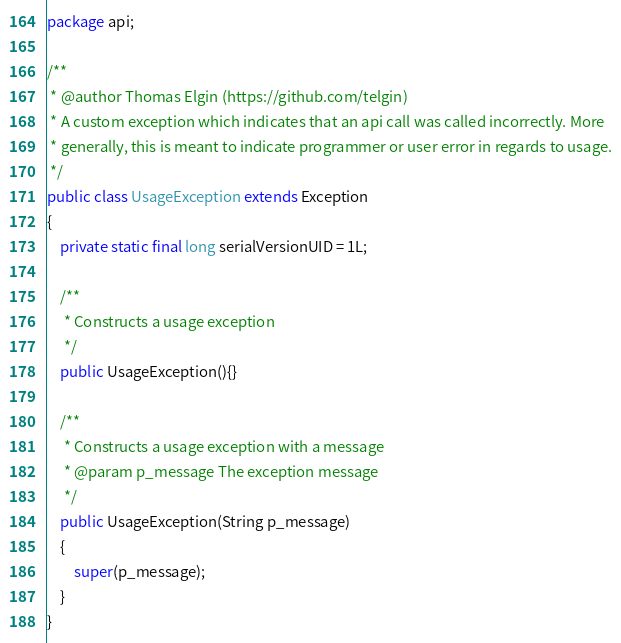Convert code to text. <code><loc_0><loc_0><loc_500><loc_500><_Java_>package api;

/**
 * @author Thomas Elgin (https://github.com/telgin)
 * A custom exception which indicates that an api call was called incorrectly. More
 * generally, this is meant to indicate programmer or user error in regards to usage.
 */
public class UsageException extends Exception
{
	private static final long serialVersionUID = 1L;

	/**
	 * Constructs a usage exception
	 */
	public UsageException(){}
	
	/**
	 * Constructs a usage exception with a message
	 * @param p_message The exception message
	 */
	public UsageException(String p_message)
	{
		super(p_message);
	}
}
</code> 